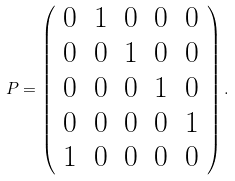<formula> <loc_0><loc_0><loc_500><loc_500>P = \left ( \begin{array} { c c c c c } 0 & 1 & 0 & 0 & 0 \\ 0 & 0 & 1 & 0 & 0 \\ 0 & 0 & 0 & 1 & 0 \\ 0 & 0 & 0 & 0 & 1 \\ 1 & 0 & 0 & 0 & 0 \end{array} \right ) .</formula> 